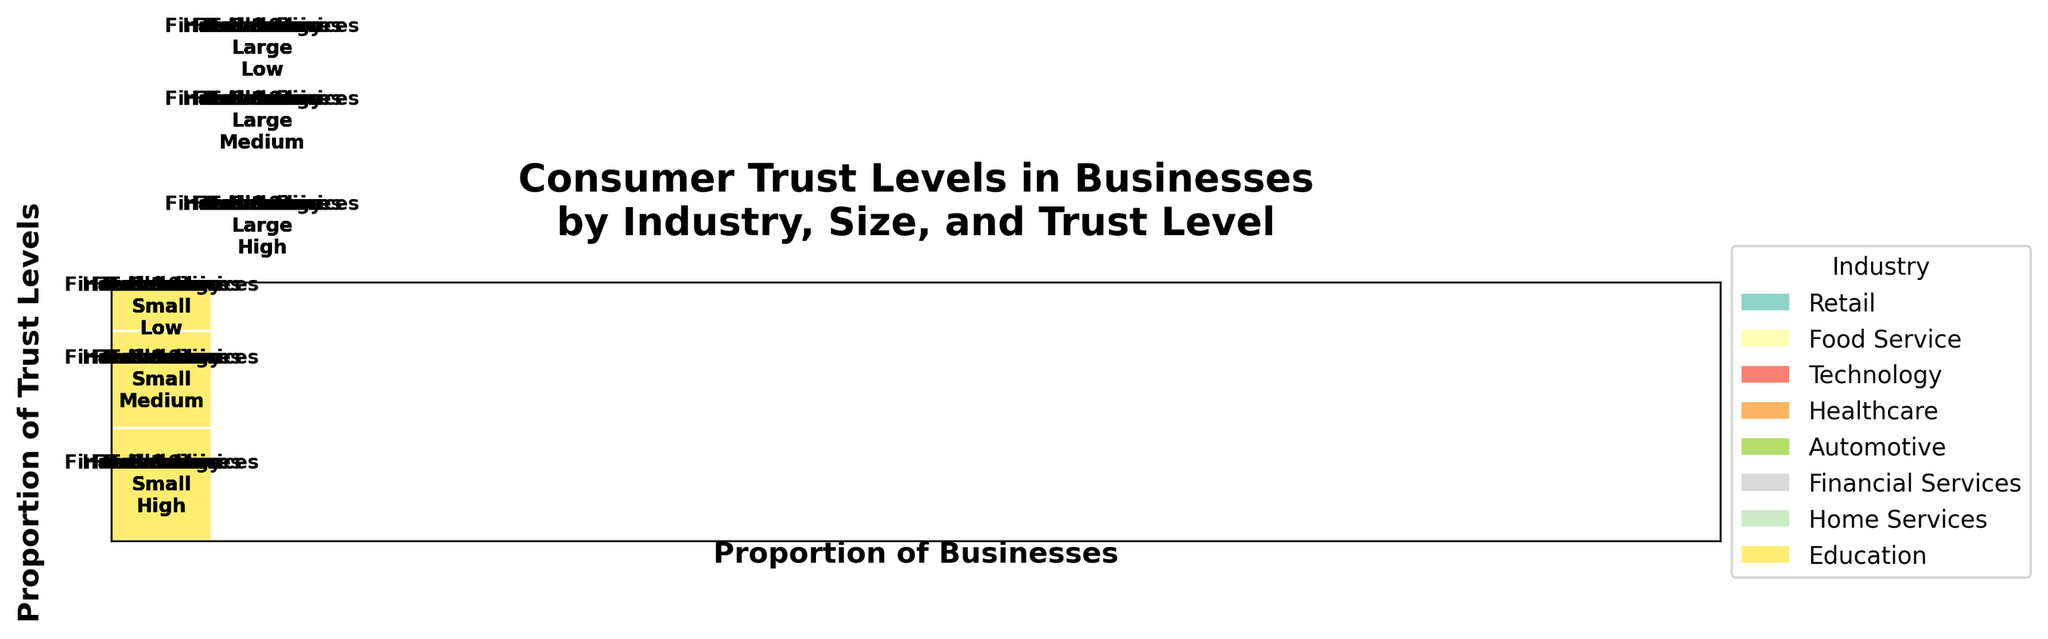What are the main industries shown in the plot? The plot legend lists all the main industries, which are distinguished by different colors. By examining the legend on the right side of the plot, one can identify these industries.
Answer: Retail, Food Service, Technology, Healthcare, Automotive, Financial Services, Home Services, Education Which business size appears to have higher trust levels in the Education industry? Each rectangle is labeled with the industry, business size, and trust level. By locating the Education industry and examining the trust levels associated with Small and Large businesses, it's clear which has the higher trust.
Answer: Small What business practices are associated with high trust levels in the Healthcare industry? Each industry section in the plot includes text detailing the business practices linked to various trust levels. By focusing on the Healthcare industry and identifying the 'High' trust level entries, one can determine the associated business practices.
Answer: Individualized care How does consumer trust in small Retail businesses compare to large ones regarding 'Transparent pricing' and 'Loyalty programs'? We need to find the Retail industry's sections for Small and Large businesses, then compare their trust levels and related business practices. Small businesses with 'Transparent pricing' have high trust, while large businesses with 'Loyalty programs' have medium trust.
Answer: Small businesses have higher trust Which industry has the lowest trust level for large businesses? By analyzing the sections for large businesses across all industries and comparing their trust levels, we can identify which industry has the lowest trust level. The Automotive industry, with 'Aggressive sales tactics,' has 'Low' trust level.
Answer: Automotive Does the Technology industry show higher trust levels in small or large businesses? By comparing the rectangles for Small and Large businesses within the Technology industry, we can see which has higher trust levels. Small businesses have a 'Medium' trust level, and large ones have 'High' trust level.
Answer: Large What business practice is correlated with medium trust levels in the Financial Services industry? For the Financial Services industry, examine the business practices listed within the 'Medium' trust rectangles. The only business practice listed across different companies' trust levels is 'Community-focused lending.'
Answer: Community-focused lending Are there more high trust levels observed among small or large businesses across all industries? Count the rectangles labeled 'High' for both Small and Large businesses across all industries. There are more high trust levels among small businesses, as observed in multiple industries.
Answer: Small Which industry exhibits a business practice specifically mentioned as '24/7 availability'? This can be found by scanning the business practices listed in the plot's rectangles until '24/7 availability' is found, and noting the associated industry. It appears in the Home Services industry.
Answer: Home Services 